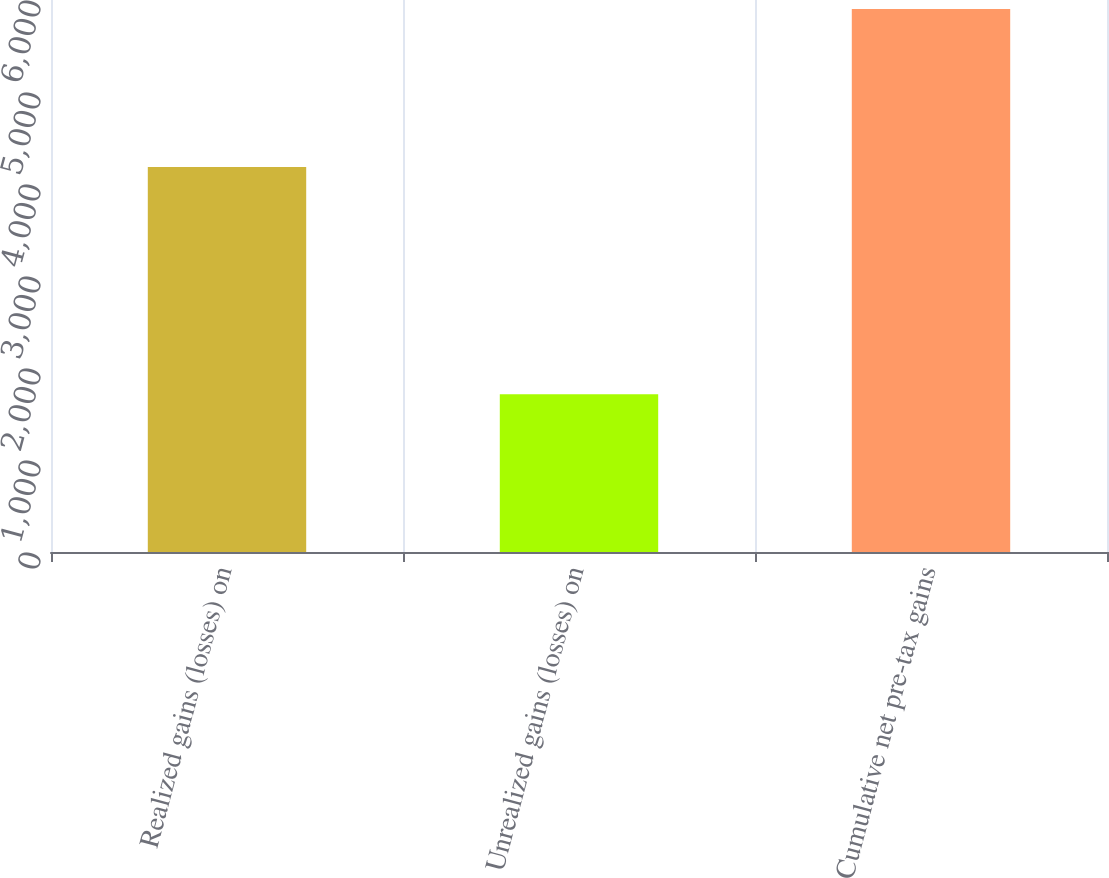<chart> <loc_0><loc_0><loc_500><loc_500><bar_chart><fcel>Realized gains (losses) on<fcel>Unrealized gains (losses) on<fcel>Cumulative net pre-tax gains<nl><fcel>4186<fcel>1716<fcel>5902<nl></chart> 